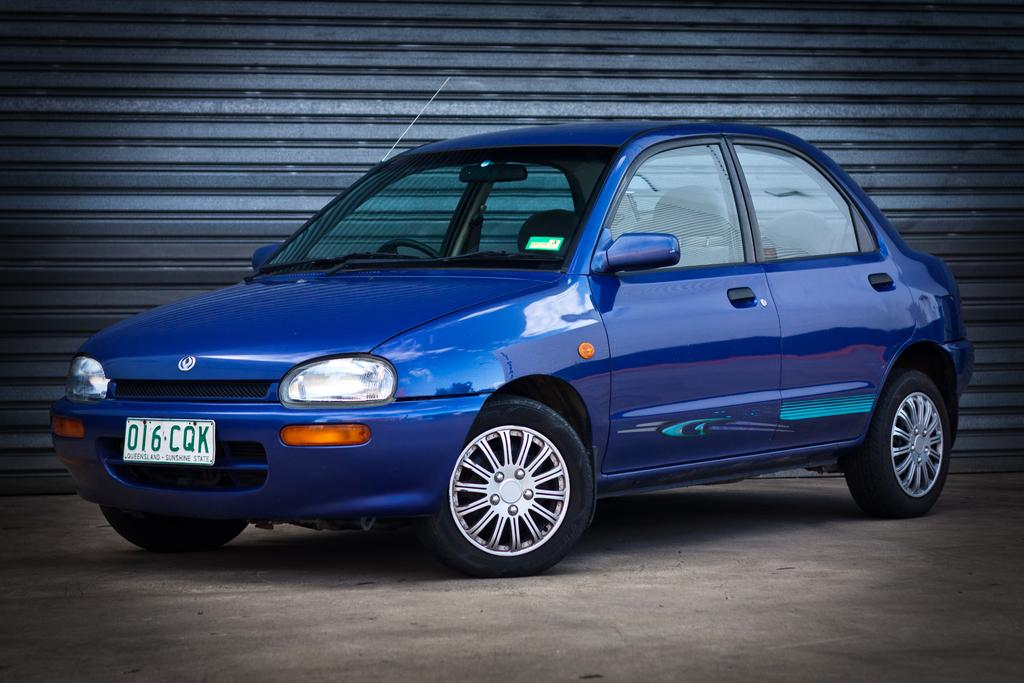What is the main subject of the image? The main subject of the image is a car. Can you describe the car's appearance? The car is blue in color and has headlights. Is there any identifying information on the car? Yes, the car has a number plate. What is the setting of the image? The image features a road and a shutter. What type of lead can be seen connecting the car to the shutter in the image? There is no lead connecting the car to the shutter in the image. The car and shutter are separate subjects in the image. 